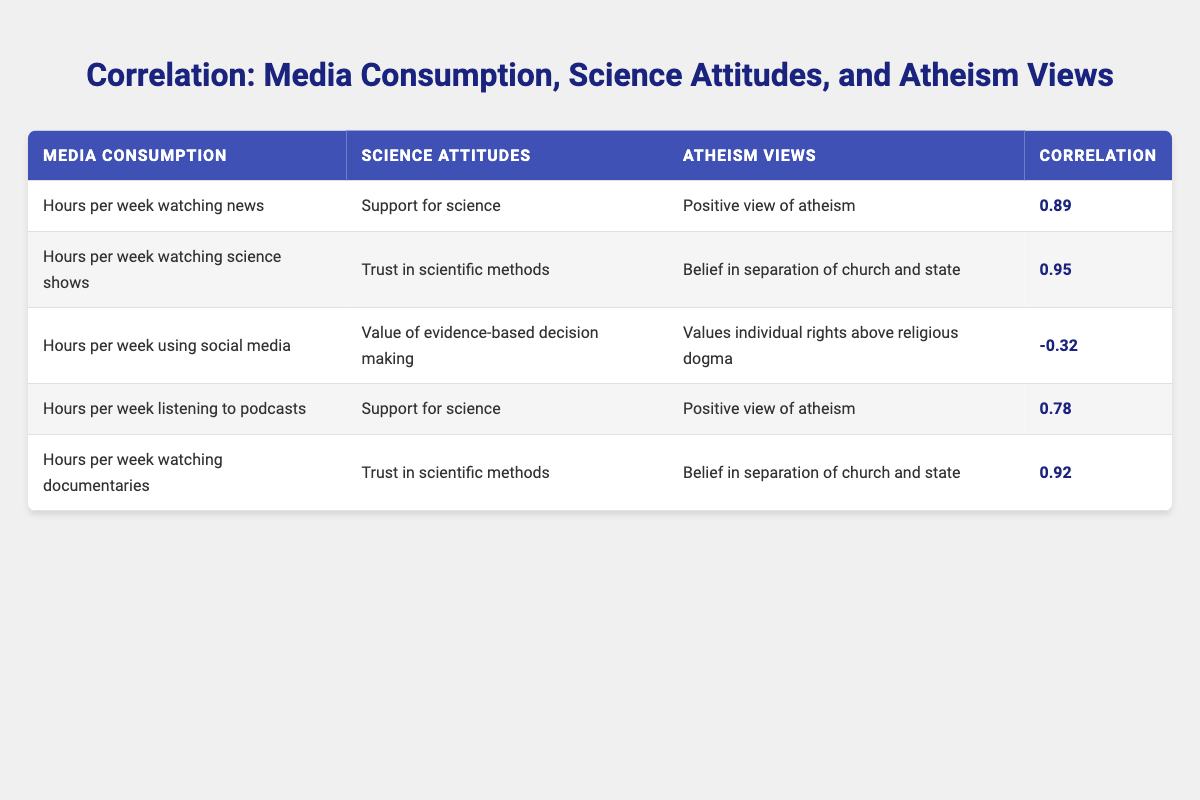What is the correlation between hours spent watching news and support for science? The table shows that the correlation is 0.89 between hours spent watching news and support for science.
Answer: 0.89 How does the correlation between hours spent watching documentaries and trust in scientific methods compare to that of hours spent listening to podcasts and support for science? The correlation for documentaries and trust in scientific methods is 0.92 while the correlation for podcasts and support for science is 0.78. Thus, documentaries have a stronger correlation.
Answer: 0.92 vs 0.78 Is there a negative correlation between hours spent on social media and the value of evidence-based decision making? The table indicates the correlation is -0.32, confirming that there is a negative correlation.
Answer: Yes What is the average correlation of all media consumption variables with support for science? The correlations are 0.89 (news), 0.78 (podcasts). To find the average, add these two correlations and divide by 2: (0.89 + 0.78) / 2 = 0.835.
Answer: 0.835 Which media consumption habit has the highest correlation with belief in separation of church and state? The highest correlation with belief in separation of church and state comes from hours spent watching science shows, with a correlation of 0.95.
Answer: 0.95 What media consumption variable has the weakest correlation with positive views of atheism? The variable with the weakest correlation to positive views of atheism is hours spent on social media, with a correlation of -0.32.
Answer: -0.32 Is there a correlation above 0.90 between a media consumption habit and any of the corresponding attitudes? Yes, there are correlations above 0.90, specifically for hours spent watching science shows and trust in scientific methods (0.95) as well as hours spent watching documentaries and trust in scientific methods (0.92).
Answer: Yes Which has a higher correlation with positive views of atheism: hours spent on listening to podcasts or hours spent watching science shows? The correlation for hours spent listening to podcasts and positive views of atheism is 0.78, while hours spent watching science shows does not have a direct correlation for that; thus, podcasts have a correlation for positive views of atheism.
Answer: Podcasts have a higher correlation 